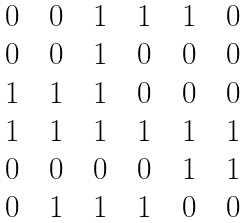<formula> <loc_0><loc_0><loc_500><loc_500>\begin{matrix} 0 \quad 0 \quad 1 \quad 1 \quad 1 \quad 0 \\ 0 \quad 0 \quad 1 \quad 0 \quad 0 \quad 0 \\ 1 \quad 1 \quad 1 \quad 0 \quad 0 \quad 0 \\ 1 \quad 1 \quad 1 \quad 1 \quad 1 \quad 1 \\ 0 \quad 0 \quad 0 \quad 0 \quad 1 \quad 1 \\ 0 \quad 1 \quad 1 \quad 1 \quad 0 \quad 0 \\ \end{matrix}</formula> 